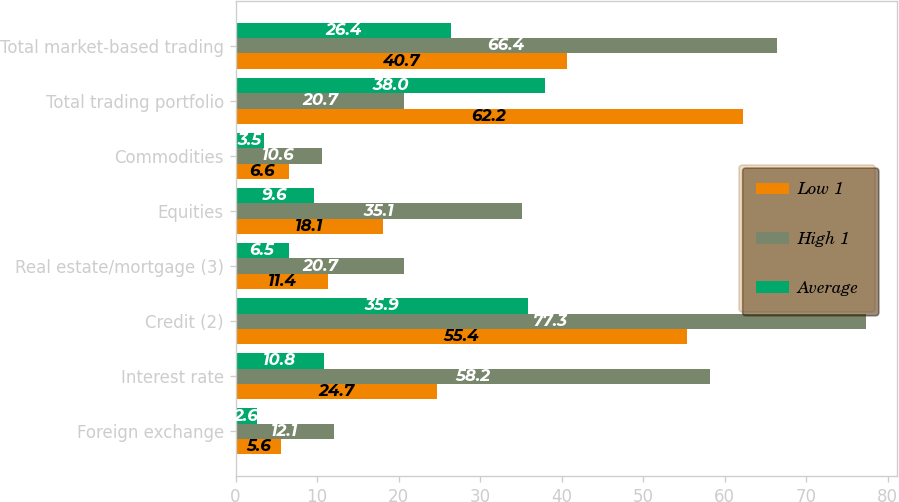<chart> <loc_0><loc_0><loc_500><loc_500><stacked_bar_chart><ecel><fcel>Foreign exchange<fcel>Interest rate<fcel>Credit (2)<fcel>Real estate/mortgage (3)<fcel>Equities<fcel>Commodities<fcel>Total trading portfolio<fcel>Total market-based trading<nl><fcel>Low 1<fcel>5.6<fcel>24.7<fcel>55.4<fcel>11.4<fcel>18.1<fcel>6.6<fcel>62.2<fcel>40.7<nl><fcel>High 1<fcel>12.1<fcel>58.2<fcel>77.3<fcel>20.7<fcel>35.1<fcel>10.6<fcel>20.7<fcel>66.4<nl><fcel>Average<fcel>2.6<fcel>10.8<fcel>35.9<fcel>6.5<fcel>9.6<fcel>3.5<fcel>38<fcel>26.4<nl></chart> 